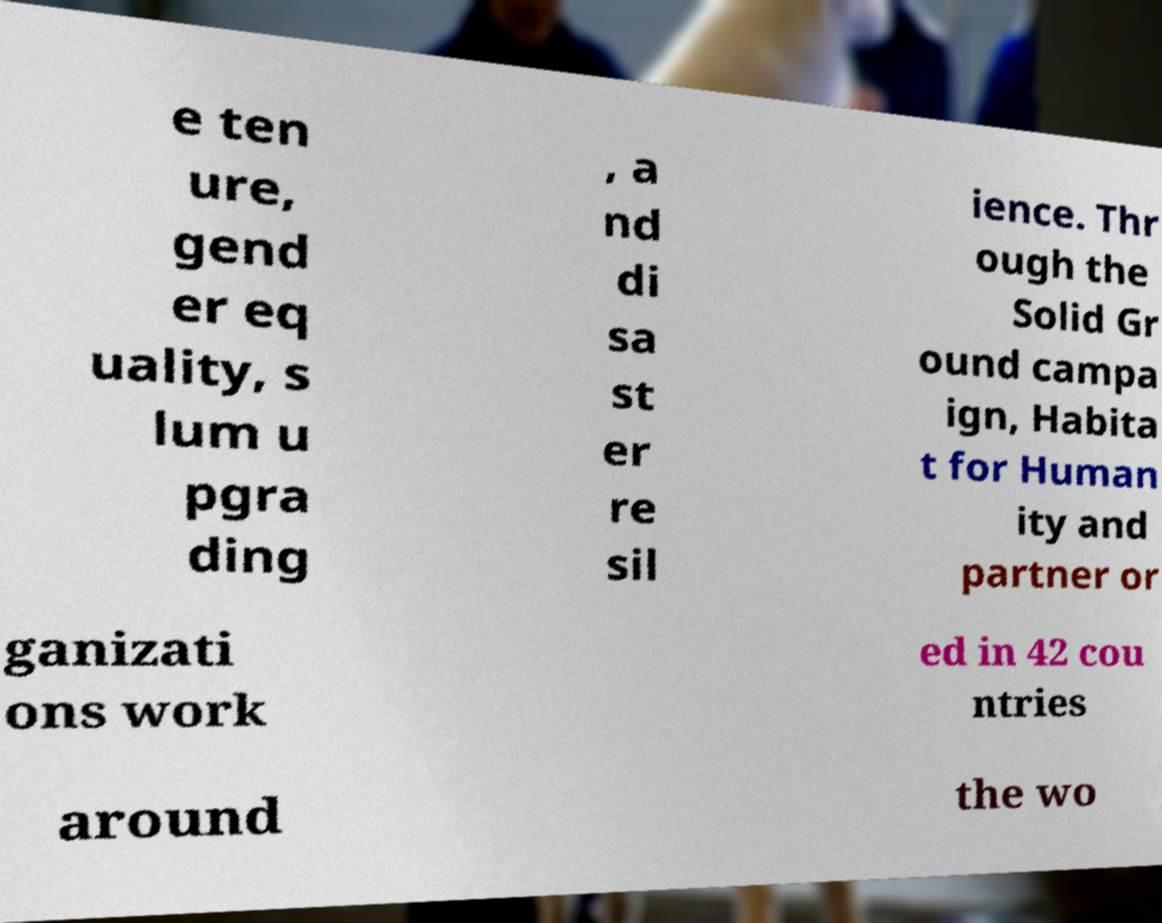Can you read and provide the text displayed in the image?This photo seems to have some interesting text. Can you extract and type it out for me? e ten ure, gend er eq uality, s lum u pgra ding , a nd di sa st er re sil ience. Thr ough the Solid Gr ound campa ign, Habita t for Human ity and partner or ganizati ons work ed in 42 cou ntries around the wo 